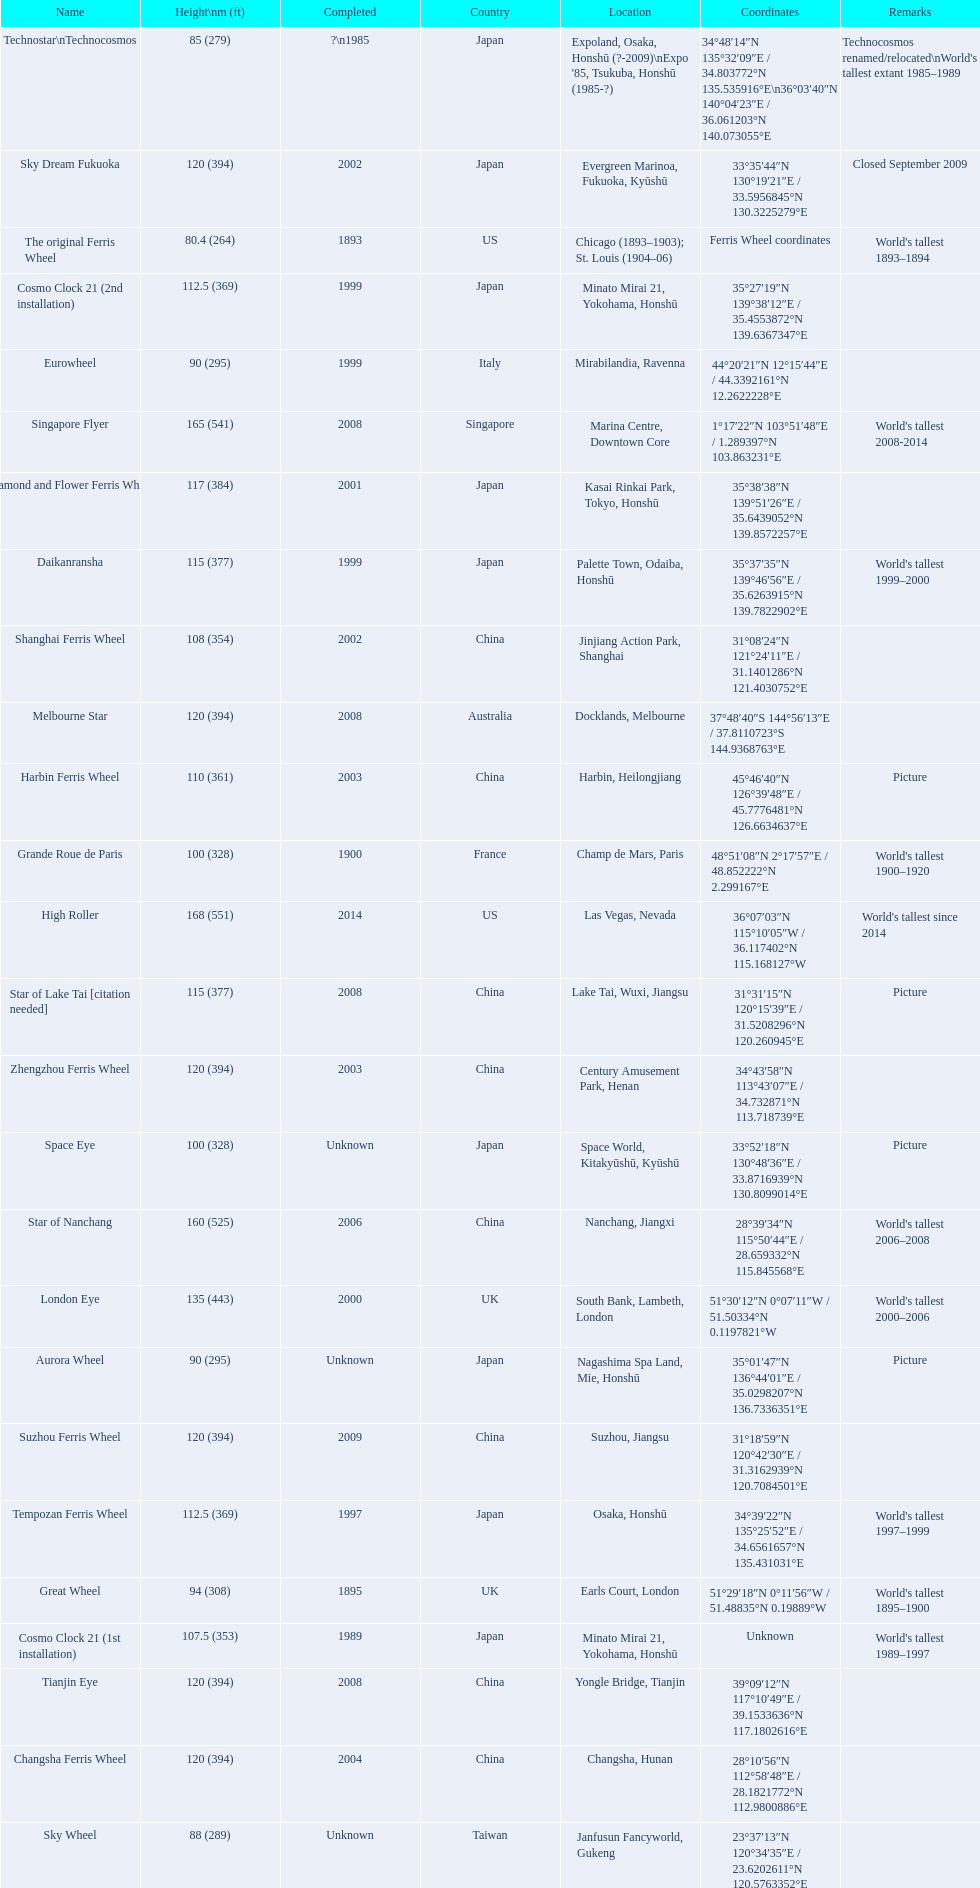When was the high roller ferris wheel completed? 2014. Which ferris wheel was completed in 2006? Star of Nanchang. Which one was completed in 2008? Singapore Flyer. 